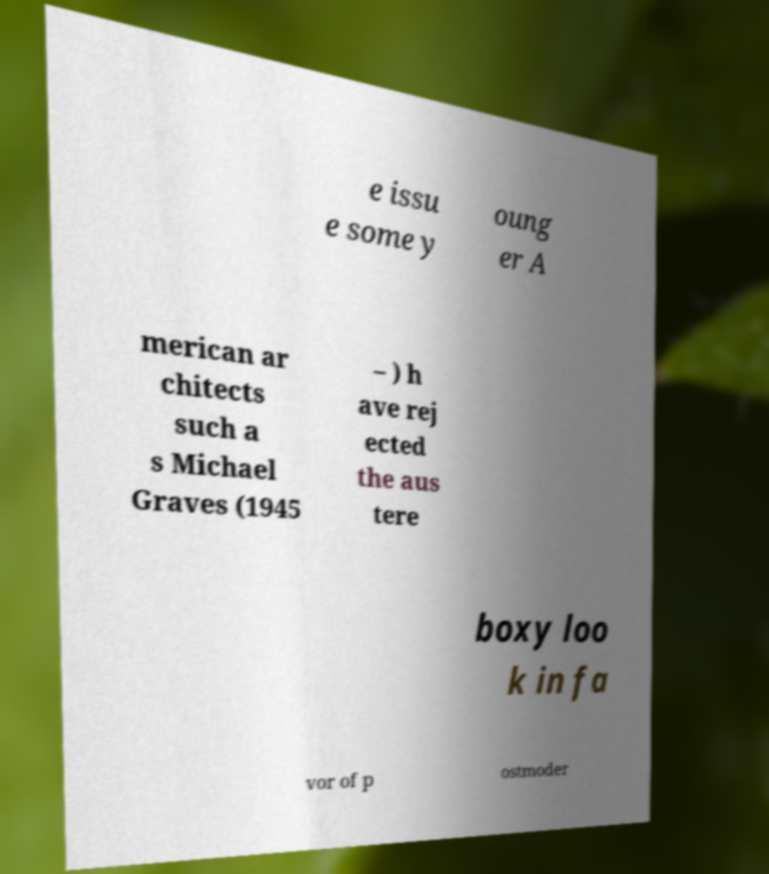Please identify and transcribe the text found in this image. e issu e some y oung er A merican ar chitects such a s Michael Graves (1945 – ) h ave rej ected the aus tere boxy loo k in fa vor of p ostmoder 